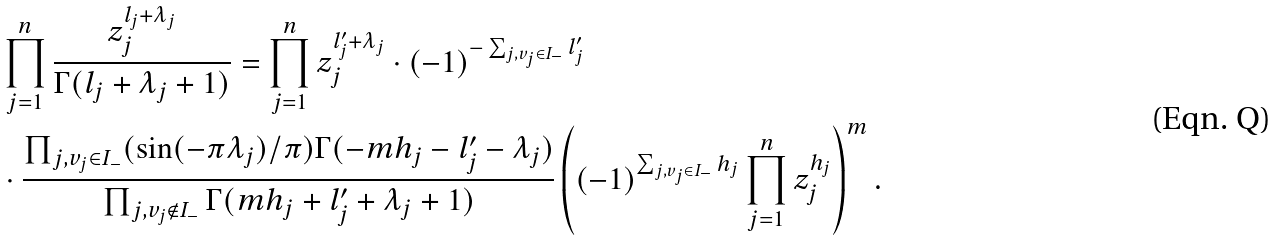<formula> <loc_0><loc_0><loc_500><loc_500>& \prod _ { j = 1 } ^ { n } \frac { z ^ { l _ { j } + \lambda _ { j } } _ { j } } { \Gamma ( l _ { j } + \lambda _ { j } + 1 ) } = \prod _ { j = 1 } ^ { n } z _ { j } ^ { l _ { j } ^ { \prime } + \lambda _ { j } } \cdot ( - 1 ) ^ { - \sum _ { j , v _ { j } \in I _ { - } } l _ { j } ^ { \prime } } \\ & \cdot \frac { \prod _ { j , v _ { j } \in I _ { - } } ( \sin ( - \pi \lambda _ { j } ) / \pi ) \Gamma ( - m h _ { j } - l _ { j } ^ { \prime } - \lambda _ { j } ) } { \prod _ { j , v _ { j } \notin I _ { - } } \Gamma ( m h _ { j } + l _ { j } ^ { \prime } + \lambda _ { j } + 1 ) } \left ( ( - 1 ) ^ { \sum _ { j , v _ { j } \in I _ { - } } h _ { j } } \prod _ { j = 1 } ^ { n } z _ { j } ^ { h _ { j } } \right ) ^ { m } .</formula> 